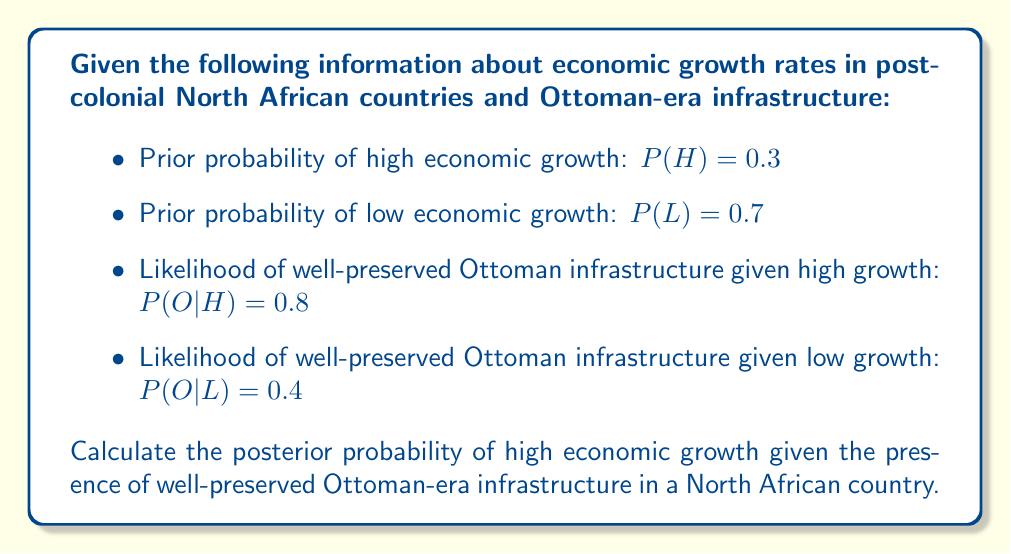Can you solve this math problem? To solve this problem, we'll use Bayes' theorem:

$$P(H|O) = \frac{P(O|H) \cdot P(H)}{P(O)}$$

Where:
- $P(H|O)$ is the posterior probability of high growth given Ottoman infrastructure
- $P(O|H)$ is the likelihood of Ottoman infrastructure given high growth
- $P(H)$ is the prior probability of high growth
- $P(O)$ is the total probability of Ottoman infrastructure

We're given $P(O|H) = 0.8$, $P(H) = 0.3$, and $P(O|L) = 0.4$, $P(L) = 0.7$

First, calculate $P(O)$ using the law of total probability:

$$P(O) = P(O|H) \cdot P(H) + P(O|L) \cdot P(L)$$
$$P(O) = 0.8 \cdot 0.3 + 0.4 \cdot 0.7 = 0.24 + 0.28 = 0.52$$

Now we can apply Bayes' theorem:

$$P(H|O) = \frac{0.8 \cdot 0.3}{0.52} = \frac{0.24}{0.52} = \frac{12}{26} \approx 0.4615$$
Answer: The posterior probability of high economic growth given well-preserved Ottoman-era infrastructure is approximately 0.4615 or 46.15%. 